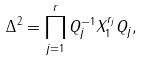<formula> <loc_0><loc_0><loc_500><loc_500>\Delta ^ { 2 } = \prod _ { j = 1 } ^ { r } Q _ { j } ^ { - 1 } X _ { 1 } ^ { r _ { j } } Q _ { j } ,</formula> 